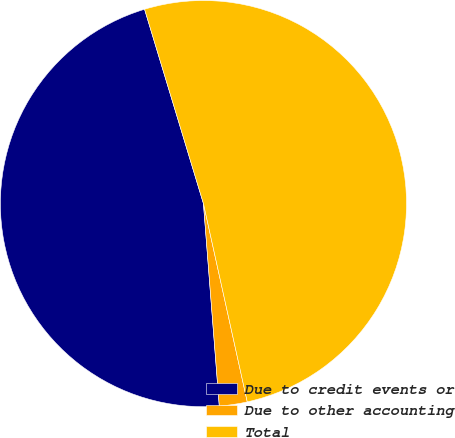Convert chart. <chart><loc_0><loc_0><loc_500><loc_500><pie_chart><fcel>Due to credit events or<fcel>Due to other accounting<fcel>Total<nl><fcel>46.56%<fcel>2.22%<fcel>51.22%<nl></chart> 